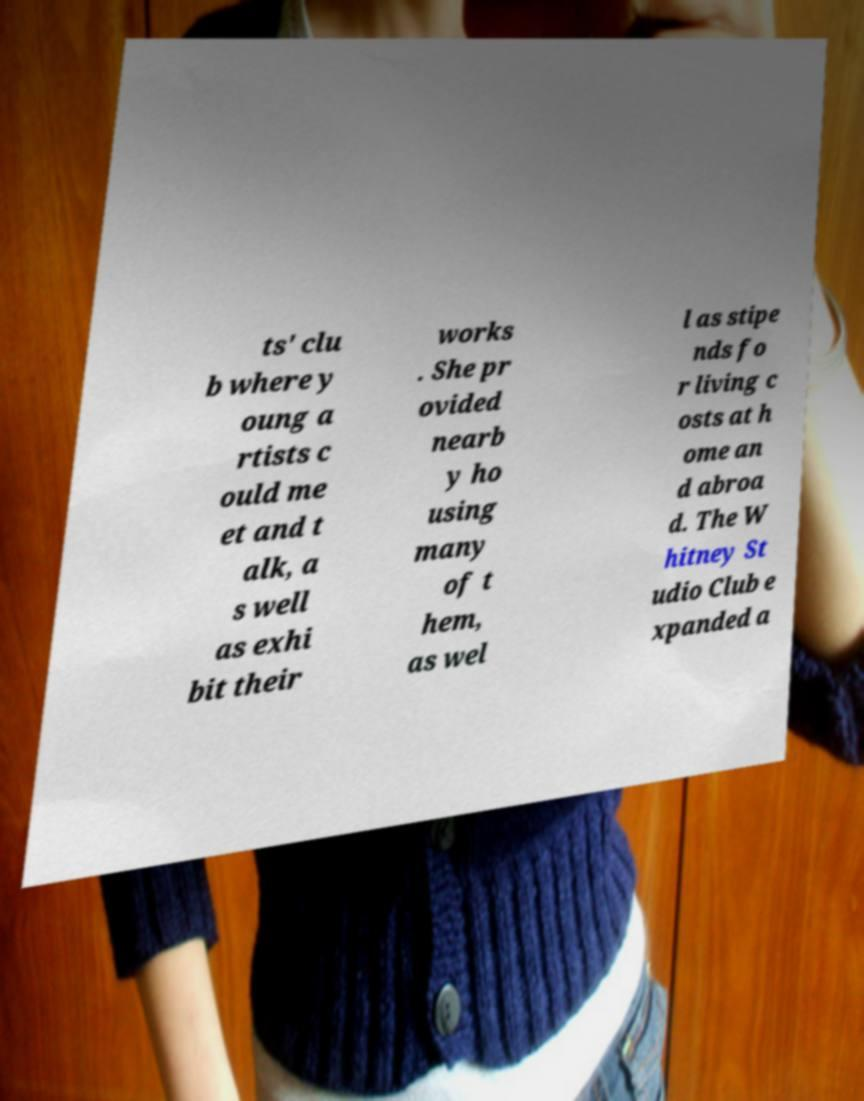For documentation purposes, I need the text within this image transcribed. Could you provide that? ts' clu b where y oung a rtists c ould me et and t alk, a s well as exhi bit their works . She pr ovided nearb y ho using many of t hem, as wel l as stipe nds fo r living c osts at h ome an d abroa d. The W hitney St udio Club e xpanded a 